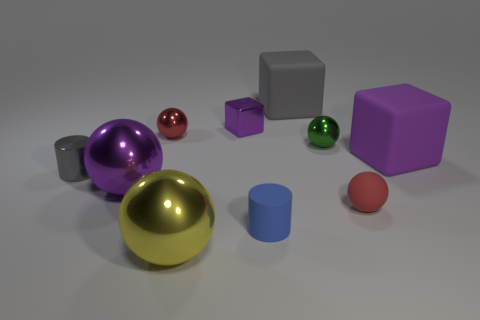The tiny thing that is the same color as the matte sphere is what shape?
Your answer should be compact. Sphere. Is the number of blue rubber things less than the number of cylinders?
Your answer should be compact. Yes. Are there any cylinders that have the same size as the red metal thing?
Ensure brevity in your answer.  Yes. Do the small green object and the small red thing behind the green object have the same shape?
Keep it short and to the point. Yes. How many cubes are either small green metal objects or gray metal objects?
Offer a terse response. 0. What color is the shiny block?
Make the answer very short. Purple. Are there more gray rubber cubes than tiny purple metallic spheres?
Make the answer very short. Yes. What number of objects are cubes left of the gray matte block or cyan matte cylinders?
Your answer should be compact. 1. Do the yellow sphere and the blue object have the same material?
Offer a terse response. No. The gray metallic thing that is the same shape as the tiny blue thing is what size?
Keep it short and to the point. Small. 